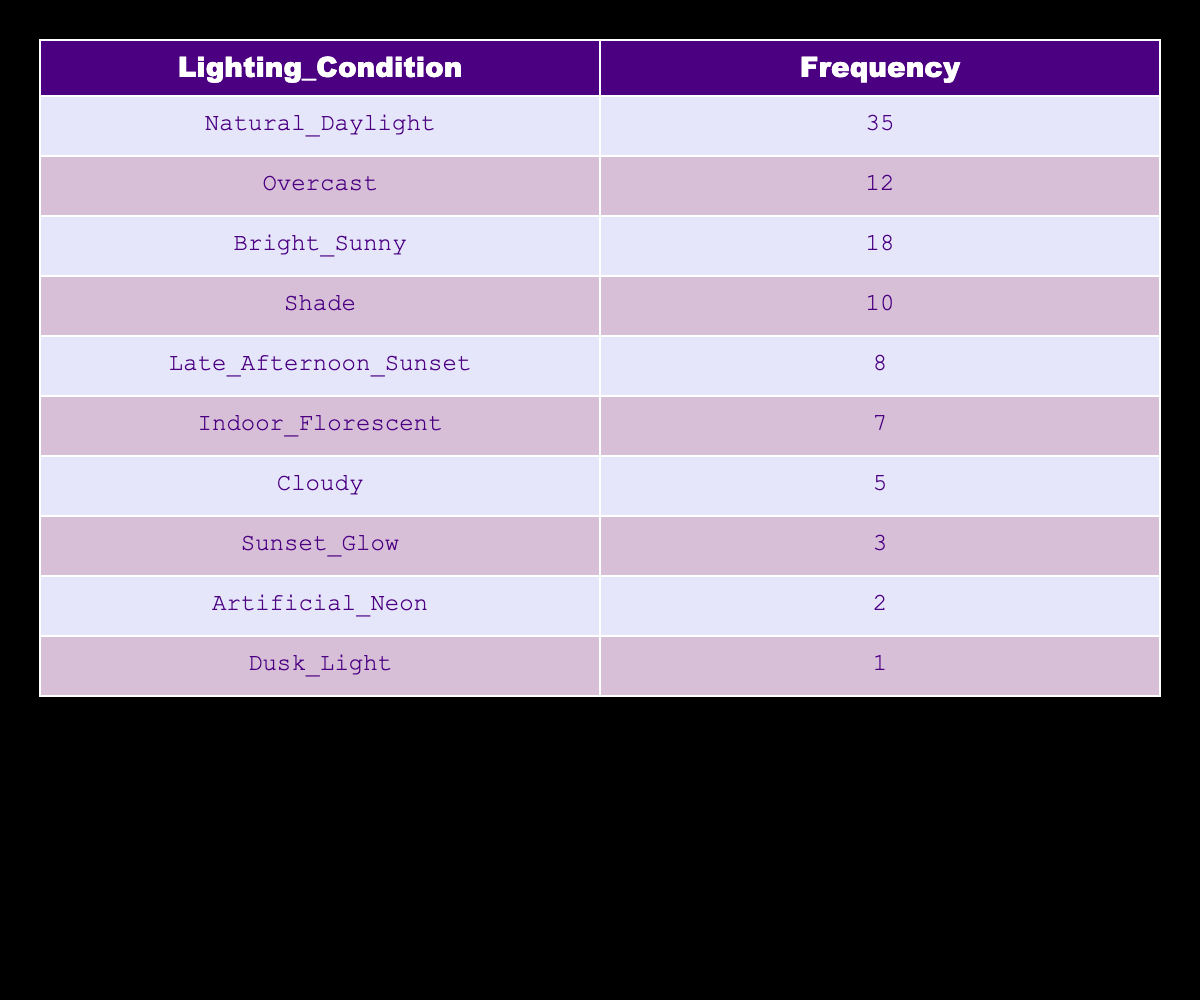What is the frequency of archery events held in natural daylight? The table shows that the frequency of archery events held in natural daylight is listed under the "Frequency" column next to "Natural_Daylight." The value is 35.
Answer: 35 How many more events were held in bright sunny conditions than in shade? To answer this, we look at the values for "Bright_Sunny," which has a frequency of 18, and "Shade," which has a frequency of 10. The difference is 18 - 10 = 8.
Answer: 8 Is indoor fluorescent lighting used for more events than dusk light? By checking the frequencies, indoor fluorescent has a frequency of 7 while dusk light has a frequency of 1. Since 7 is greater than 1, the statement is true.
Answer: Yes What is the total number of events held under overcast and cloudy conditions? We sum the frequencies for "Overcast," which has a frequency of 12, and "Cloudy," which has a frequency of 5. The total is 12 + 5 = 17.
Answer: 17 Which lighting condition has the least number of events, and how many events were held? The lighting condition with the least number of events is "Dusk_Light," which has a frequency of 1. This information is directly found in the table.
Answer: Dusk Light, 1 How many events were held under all artificial lighting conditions combined, including both artificial neon and indoor fluorescent? We need to add the values for "Artificial_Neon," which has a frequency of 2, and "Indoor_Florescent," which has a frequency of 7. Thus, 2 + 7 = 9 events were held under artificial lighting.
Answer: 9 What is the average number of events for all lighting conditions? We add all the frequencies: (35 + 12 + 18 + 10 + 8 + 7 + 5 + 3 + 2 + 1) = 91 total events, and there are 10 different lighting conditions. The average is then 91/10 = 9.1.
Answer: 9.1 